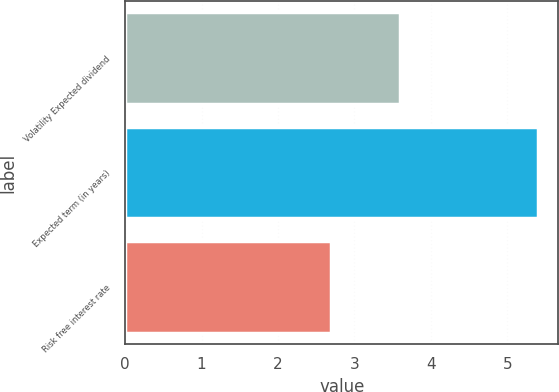Convert chart. <chart><loc_0><loc_0><loc_500><loc_500><bar_chart><fcel>Volatility Expected dividend<fcel>Expected term (in years)<fcel>Risk free interest rate<nl><fcel>3.6<fcel>5.4<fcel>2.7<nl></chart> 